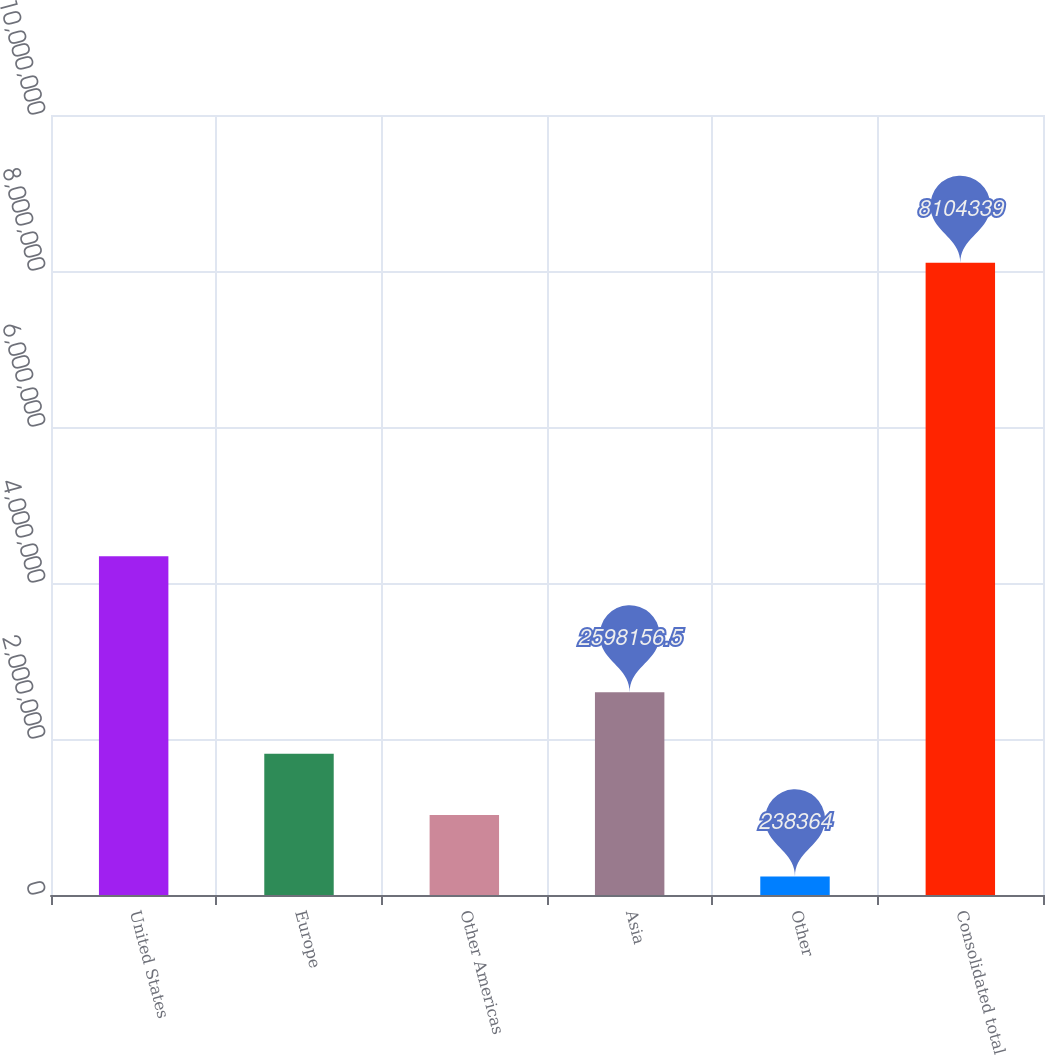Convert chart. <chart><loc_0><loc_0><loc_500><loc_500><bar_chart><fcel>United States<fcel>Europe<fcel>Other Americas<fcel>Asia<fcel>Other<fcel>Consolidated total<nl><fcel>4.34395e+06<fcel>1.81156e+06<fcel>1.02496e+06<fcel>2.59816e+06<fcel>238364<fcel>8.10434e+06<nl></chart> 